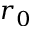Convert formula to latex. <formula><loc_0><loc_0><loc_500><loc_500>r _ { 0 }</formula> 